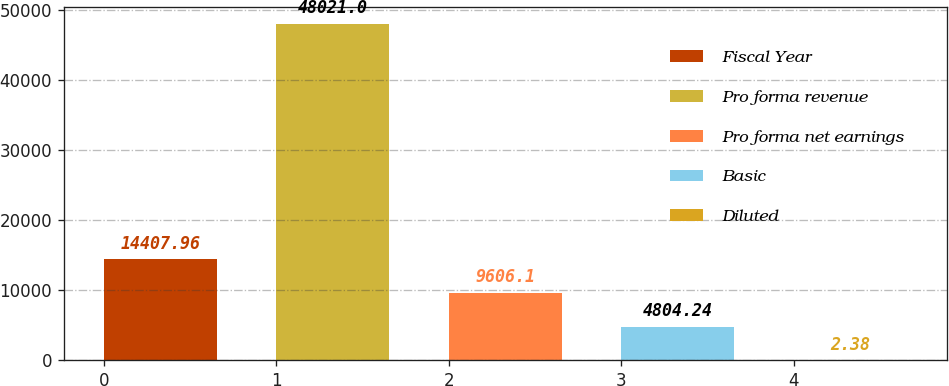Convert chart to OTSL. <chart><loc_0><loc_0><loc_500><loc_500><bar_chart><fcel>Fiscal Year<fcel>Pro forma revenue<fcel>Pro forma net earnings<fcel>Basic<fcel>Diluted<nl><fcel>14408<fcel>48021<fcel>9606.1<fcel>4804.24<fcel>2.38<nl></chart> 